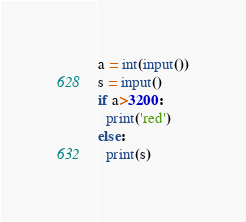Convert code to text. <code><loc_0><loc_0><loc_500><loc_500><_Python_>a = int(input())
s = input()
if a>3200:
  print('red')
else:
  print(s)</code> 